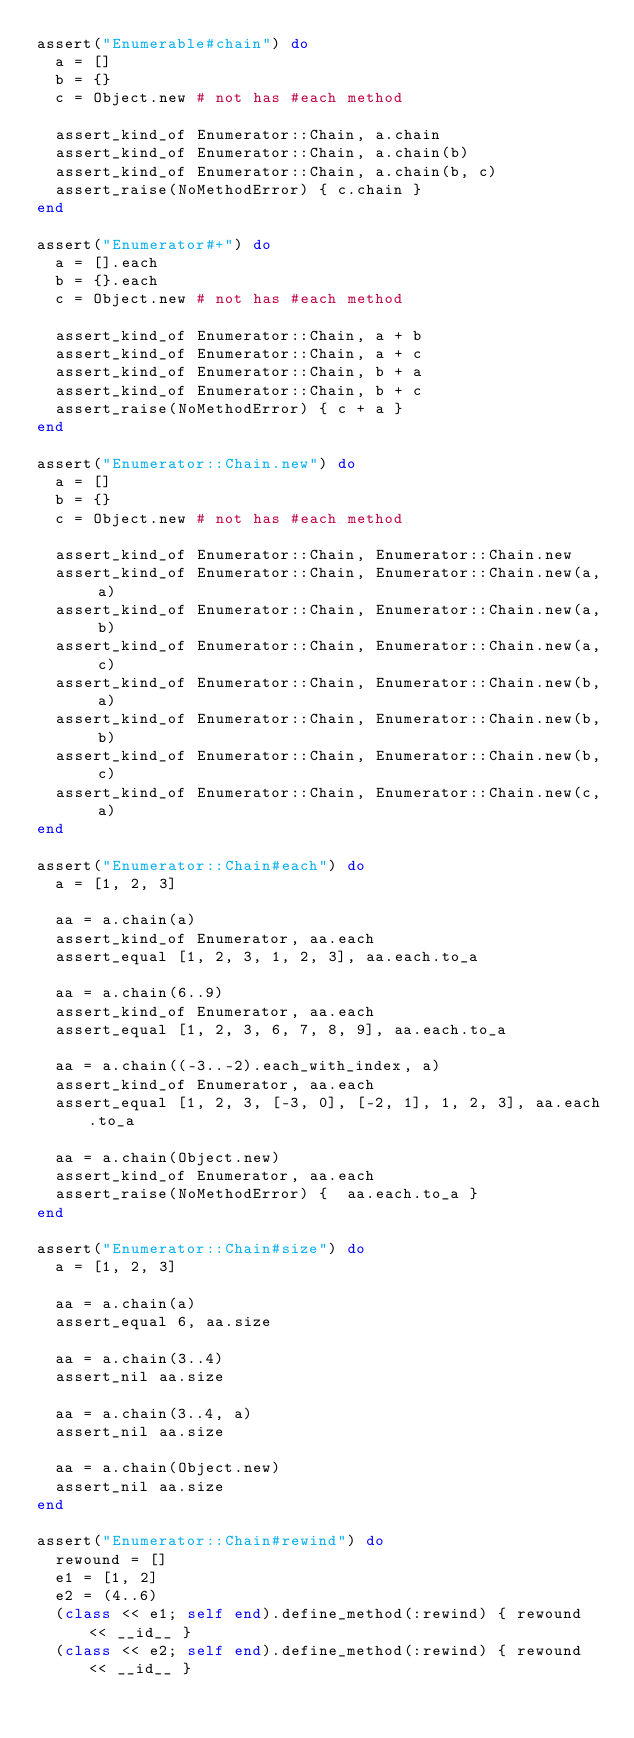<code> <loc_0><loc_0><loc_500><loc_500><_Ruby_>assert("Enumerable#chain") do
  a = []
  b = {}
  c = Object.new # not has #each method

  assert_kind_of Enumerator::Chain, a.chain
  assert_kind_of Enumerator::Chain, a.chain(b)
  assert_kind_of Enumerator::Chain, a.chain(b, c)
  assert_raise(NoMethodError) { c.chain }
end

assert("Enumerator#+") do
  a = [].each
  b = {}.each
  c = Object.new # not has #each method

  assert_kind_of Enumerator::Chain, a + b
  assert_kind_of Enumerator::Chain, a + c
  assert_kind_of Enumerator::Chain, b + a
  assert_kind_of Enumerator::Chain, b + c
  assert_raise(NoMethodError) { c + a }
end

assert("Enumerator::Chain.new") do
  a = []
  b = {}
  c = Object.new # not has #each method

  assert_kind_of Enumerator::Chain, Enumerator::Chain.new
  assert_kind_of Enumerator::Chain, Enumerator::Chain.new(a, a)
  assert_kind_of Enumerator::Chain, Enumerator::Chain.new(a, b)
  assert_kind_of Enumerator::Chain, Enumerator::Chain.new(a, c)
  assert_kind_of Enumerator::Chain, Enumerator::Chain.new(b, a)
  assert_kind_of Enumerator::Chain, Enumerator::Chain.new(b, b)
  assert_kind_of Enumerator::Chain, Enumerator::Chain.new(b, c)
  assert_kind_of Enumerator::Chain, Enumerator::Chain.new(c, a)
end

assert("Enumerator::Chain#each") do
  a = [1, 2, 3]

  aa = a.chain(a)
  assert_kind_of Enumerator, aa.each
  assert_equal [1, 2, 3, 1, 2, 3], aa.each.to_a

  aa = a.chain(6..9)
  assert_kind_of Enumerator, aa.each
  assert_equal [1, 2, 3, 6, 7, 8, 9], aa.each.to_a

  aa = a.chain((-3..-2).each_with_index, a)
  assert_kind_of Enumerator, aa.each
  assert_equal [1, 2, 3, [-3, 0], [-2, 1], 1, 2, 3], aa.each.to_a

  aa = a.chain(Object.new)
  assert_kind_of Enumerator, aa.each
  assert_raise(NoMethodError) {  aa.each.to_a }
end

assert("Enumerator::Chain#size") do
  a = [1, 2, 3]

  aa = a.chain(a)
  assert_equal 6, aa.size

  aa = a.chain(3..4)
  assert_nil aa.size

  aa = a.chain(3..4, a)
  assert_nil aa.size

  aa = a.chain(Object.new)
  assert_nil aa.size
end

assert("Enumerator::Chain#rewind") do
  rewound = []
  e1 = [1, 2]
  e2 = (4..6)
  (class << e1; self end).define_method(:rewind) { rewound << __id__ }
  (class << e2; self end).define_method(:rewind) { rewound << __id__ }</code> 